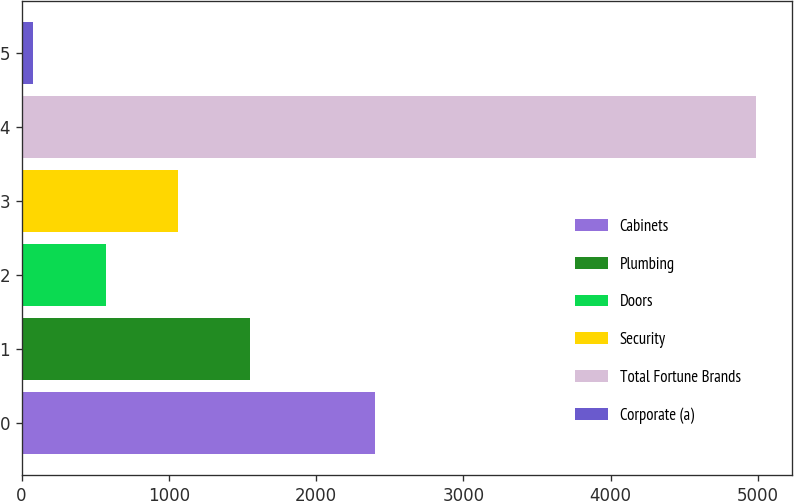Convert chart to OTSL. <chart><loc_0><loc_0><loc_500><loc_500><bar_chart><fcel>Cabinets<fcel>Plumbing<fcel>Doors<fcel>Security<fcel>Total Fortune Brands<fcel>Corporate (a)<nl><fcel>2397.8<fcel>1551.4<fcel>570.4<fcel>1060.9<fcel>4984.9<fcel>79.9<nl></chart> 